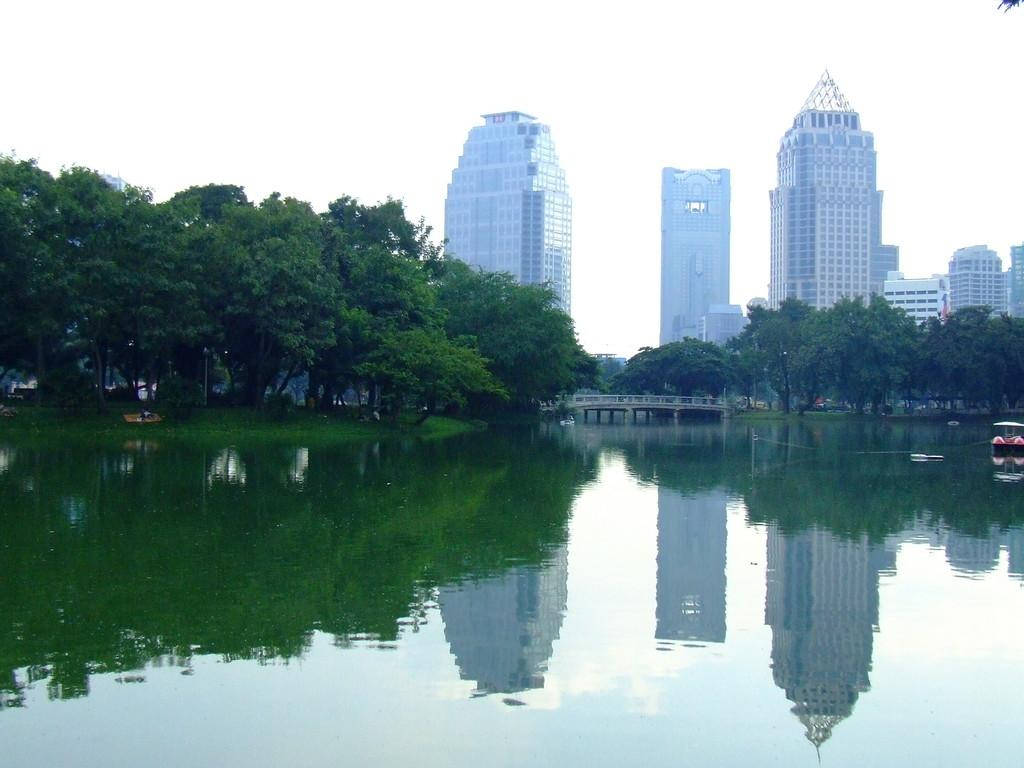What is in the water in the image? There is a boat in the water in the image. What type of vegetation can be seen in the image? Trees are visible in the image. What structure is present in the image that connects two areas? There is a bridge in the image. What type of buildings can be seen in the background of the image? Skyscrapers are present in the background of the image. What part of the natural environment is visible in the image? The sky is visible in the image. What type of riddle is written on the side of the boat in the image? There is no riddle written on the side of the boat in the image. How many tickets are needed to ride the boat in the image? There is no indication of tickets or any need for them in the image. 